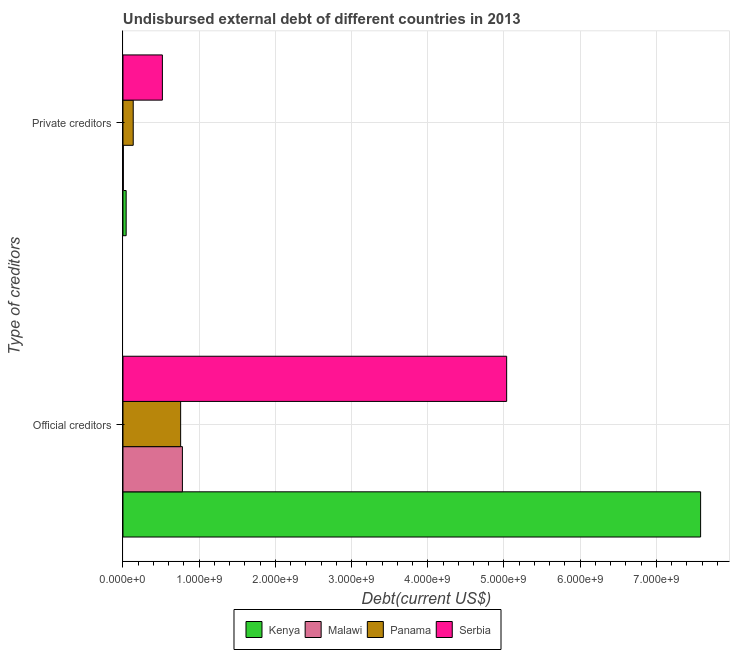How many groups of bars are there?
Your answer should be compact. 2. Are the number of bars per tick equal to the number of legend labels?
Your answer should be very brief. Yes. How many bars are there on the 1st tick from the top?
Offer a terse response. 4. How many bars are there on the 2nd tick from the bottom?
Your answer should be very brief. 4. What is the label of the 2nd group of bars from the top?
Offer a very short reply. Official creditors. What is the undisbursed external debt of official creditors in Malawi?
Keep it short and to the point. 7.80e+08. Across all countries, what is the maximum undisbursed external debt of private creditors?
Ensure brevity in your answer.  5.17e+08. Across all countries, what is the minimum undisbursed external debt of private creditors?
Your response must be concise. 4.51e+06. In which country was the undisbursed external debt of official creditors maximum?
Keep it short and to the point. Kenya. In which country was the undisbursed external debt of official creditors minimum?
Your answer should be compact. Panama. What is the total undisbursed external debt of official creditors in the graph?
Your answer should be very brief. 1.42e+1. What is the difference between the undisbursed external debt of private creditors in Kenya and that in Panama?
Offer a terse response. -9.25e+07. What is the difference between the undisbursed external debt of private creditors in Malawi and the undisbursed external debt of official creditors in Panama?
Provide a succinct answer. -7.52e+08. What is the average undisbursed external debt of private creditors per country?
Keep it short and to the point. 1.74e+08. What is the difference between the undisbursed external debt of private creditors and undisbursed external debt of official creditors in Malawi?
Offer a terse response. -7.75e+08. What is the ratio of the undisbursed external debt of private creditors in Serbia to that in Panama?
Your answer should be very brief. 3.85. What does the 4th bar from the top in Private creditors represents?
Your answer should be very brief. Kenya. What does the 3rd bar from the bottom in Official creditors represents?
Provide a succinct answer. Panama. Are all the bars in the graph horizontal?
Provide a succinct answer. Yes. What is the difference between two consecutive major ticks on the X-axis?
Offer a terse response. 1.00e+09. Are the values on the major ticks of X-axis written in scientific E-notation?
Ensure brevity in your answer.  Yes. Does the graph contain any zero values?
Offer a very short reply. No. Where does the legend appear in the graph?
Provide a succinct answer. Bottom center. What is the title of the graph?
Ensure brevity in your answer.  Undisbursed external debt of different countries in 2013. Does "Moldova" appear as one of the legend labels in the graph?
Your answer should be compact. No. What is the label or title of the X-axis?
Provide a succinct answer. Debt(current US$). What is the label or title of the Y-axis?
Provide a succinct answer. Type of creditors. What is the Debt(current US$) of Kenya in Official creditors?
Make the answer very short. 7.58e+09. What is the Debt(current US$) in Malawi in Official creditors?
Your answer should be very brief. 7.80e+08. What is the Debt(current US$) of Panama in Official creditors?
Ensure brevity in your answer.  7.57e+08. What is the Debt(current US$) of Serbia in Official creditors?
Keep it short and to the point. 5.04e+09. What is the Debt(current US$) of Kenya in Private creditors?
Provide a succinct answer. 4.18e+07. What is the Debt(current US$) in Malawi in Private creditors?
Your answer should be very brief. 4.51e+06. What is the Debt(current US$) of Panama in Private creditors?
Offer a very short reply. 1.34e+08. What is the Debt(current US$) in Serbia in Private creditors?
Provide a succinct answer. 5.17e+08. Across all Type of creditors, what is the maximum Debt(current US$) of Kenya?
Offer a very short reply. 7.58e+09. Across all Type of creditors, what is the maximum Debt(current US$) of Malawi?
Provide a short and direct response. 7.80e+08. Across all Type of creditors, what is the maximum Debt(current US$) of Panama?
Offer a very short reply. 7.57e+08. Across all Type of creditors, what is the maximum Debt(current US$) of Serbia?
Provide a short and direct response. 5.04e+09. Across all Type of creditors, what is the minimum Debt(current US$) of Kenya?
Make the answer very short. 4.18e+07. Across all Type of creditors, what is the minimum Debt(current US$) of Malawi?
Ensure brevity in your answer.  4.51e+06. Across all Type of creditors, what is the minimum Debt(current US$) in Panama?
Provide a succinct answer. 1.34e+08. Across all Type of creditors, what is the minimum Debt(current US$) in Serbia?
Provide a succinct answer. 5.17e+08. What is the total Debt(current US$) of Kenya in the graph?
Your answer should be very brief. 7.62e+09. What is the total Debt(current US$) in Malawi in the graph?
Provide a short and direct response. 7.84e+08. What is the total Debt(current US$) of Panama in the graph?
Your response must be concise. 8.91e+08. What is the total Debt(current US$) of Serbia in the graph?
Your answer should be compact. 5.55e+09. What is the difference between the Debt(current US$) of Kenya in Official creditors and that in Private creditors?
Keep it short and to the point. 7.54e+09. What is the difference between the Debt(current US$) of Malawi in Official creditors and that in Private creditors?
Keep it short and to the point. 7.75e+08. What is the difference between the Debt(current US$) in Panama in Official creditors and that in Private creditors?
Offer a very short reply. 6.22e+08. What is the difference between the Debt(current US$) in Serbia in Official creditors and that in Private creditors?
Keep it short and to the point. 4.52e+09. What is the difference between the Debt(current US$) in Kenya in Official creditors and the Debt(current US$) in Malawi in Private creditors?
Ensure brevity in your answer.  7.58e+09. What is the difference between the Debt(current US$) in Kenya in Official creditors and the Debt(current US$) in Panama in Private creditors?
Provide a succinct answer. 7.45e+09. What is the difference between the Debt(current US$) of Kenya in Official creditors and the Debt(current US$) of Serbia in Private creditors?
Provide a short and direct response. 7.06e+09. What is the difference between the Debt(current US$) of Malawi in Official creditors and the Debt(current US$) of Panama in Private creditors?
Provide a succinct answer. 6.46e+08. What is the difference between the Debt(current US$) in Malawi in Official creditors and the Debt(current US$) in Serbia in Private creditors?
Provide a short and direct response. 2.63e+08. What is the difference between the Debt(current US$) of Panama in Official creditors and the Debt(current US$) of Serbia in Private creditors?
Your answer should be compact. 2.40e+08. What is the average Debt(current US$) in Kenya per Type of creditors?
Your answer should be compact. 3.81e+09. What is the average Debt(current US$) in Malawi per Type of creditors?
Your response must be concise. 3.92e+08. What is the average Debt(current US$) of Panama per Type of creditors?
Provide a short and direct response. 4.46e+08. What is the average Debt(current US$) in Serbia per Type of creditors?
Your response must be concise. 2.78e+09. What is the difference between the Debt(current US$) in Kenya and Debt(current US$) in Malawi in Official creditors?
Provide a short and direct response. 6.80e+09. What is the difference between the Debt(current US$) in Kenya and Debt(current US$) in Panama in Official creditors?
Provide a short and direct response. 6.82e+09. What is the difference between the Debt(current US$) of Kenya and Debt(current US$) of Serbia in Official creditors?
Ensure brevity in your answer.  2.55e+09. What is the difference between the Debt(current US$) in Malawi and Debt(current US$) in Panama in Official creditors?
Keep it short and to the point. 2.31e+07. What is the difference between the Debt(current US$) of Malawi and Debt(current US$) of Serbia in Official creditors?
Ensure brevity in your answer.  -4.26e+09. What is the difference between the Debt(current US$) in Panama and Debt(current US$) in Serbia in Official creditors?
Make the answer very short. -4.28e+09. What is the difference between the Debt(current US$) of Kenya and Debt(current US$) of Malawi in Private creditors?
Offer a terse response. 3.72e+07. What is the difference between the Debt(current US$) in Kenya and Debt(current US$) in Panama in Private creditors?
Ensure brevity in your answer.  -9.25e+07. What is the difference between the Debt(current US$) of Kenya and Debt(current US$) of Serbia in Private creditors?
Give a very brief answer. -4.75e+08. What is the difference between the Debt(current US$) in Malawi and Debt(current US$) in Panama in Private creditors?
Offer a very short reply. -1.30e+08. What is the difference between the Debt(current US$) of Malawi and Debt(current US$) of Serbia in Private creditors?
Your answer should be very brief. -5.13e+08. What is the difference between the Debt(current US$) of Panama and Debt(current US$) of Serbia in Private creditors?
Provide a succinct answer. -3.83e+08. What is the ratio of the Debt(current US$) of Kenya in Official creditors to that in Private creditors?
Keep it short and to the point. 181.55. What is the ratio of the Debt(current US$) of Malawi in Official creditors to that in Private creditors?
Keep it short and to the point. 172.92. What is the ratio of the Debt(current US$) of Panama in Official creditors to that in Private creditors?
Your answer should be compact. 5.64. What is the ratio of the Debt(current US$) in Serbia in Official creditors to that in Private creditors?
Provide a short and direct response. 9.74. What is the difference between the highest and the second highest Debt(current US$) of Kenya?
Your answer should be very brief. 7.54e+09. What is the difference between the highest and the second highest Debt(current US$) in Malawi?
Your answer should be compact. 7.75e+08. What is the difference between the highest and the second highest Debt(current US$) of Panama?
Your answer should be very brief. 6.22e+08. What is the difference between the highest and the second highest Debt(current US$) in Serbia?
Your answer should be compact. 4.52e+09. What is the difference between the highest and the lowest Debt(current US$) of Kenya?
Give a very brief answer. 7.54e+09. What is the difference between the highest and the lowest Debt(current US$) of Malawi?
Keep it short and to the point. 7.75e+08. What is the difference between the highest and the lowest Debt(current US$) of Panama?
Your answer should be compact. 6.22e+08. What is the difference between the highest and the lowest Debt(current US$) of Serbia?
Offer a terse response. 4.52e+09. 